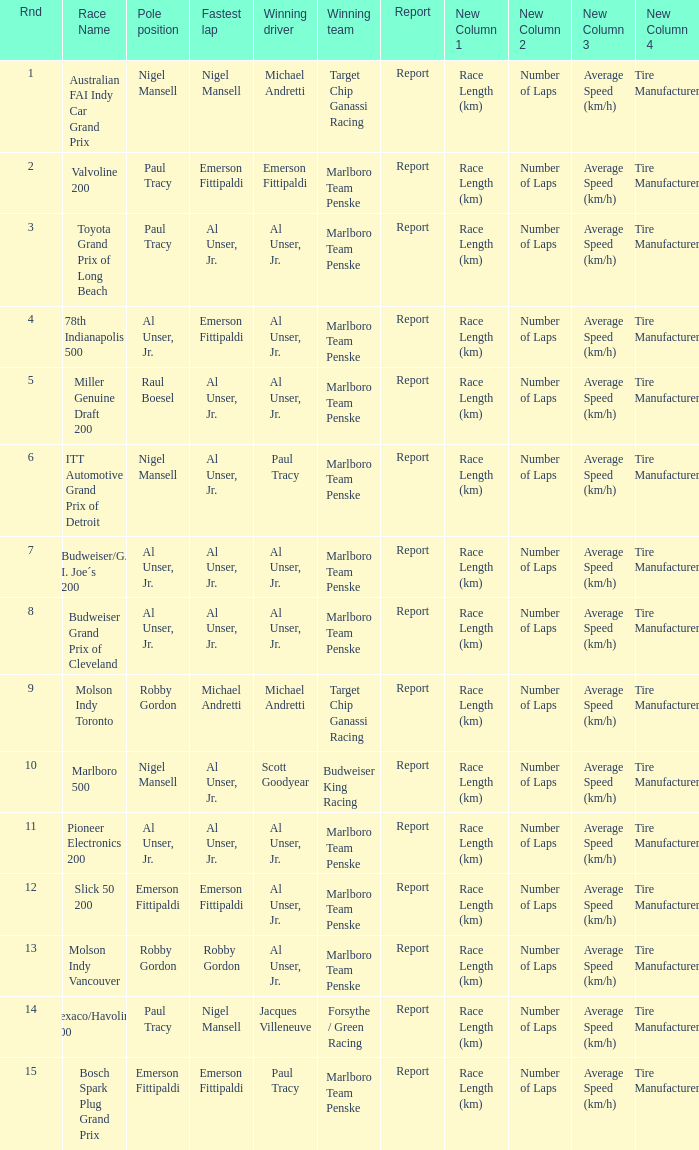Who was at the pole position in the ITT Automotive Grand Prix of Detroit, won by Paul Tracy? Nigel Mansell. 